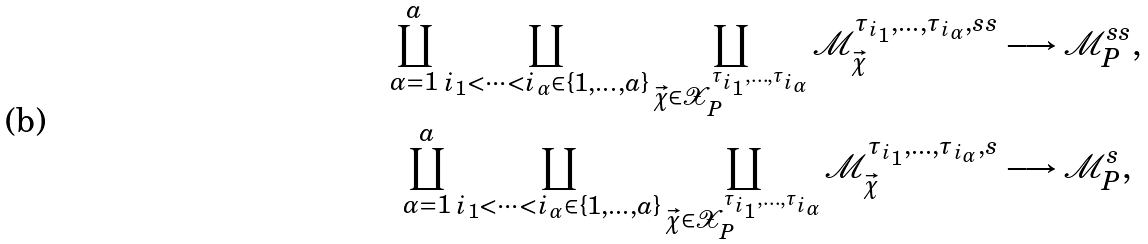<formula> <loc_0><loc_0><loc_500><loc_500>\coprod _ { \alpha = 1 } ^ { a } \coprod _ { i _ { 1 } < \cdots < i _ { \alpha } \in \{ 1 , \dots , a \} } \coprod _ { \vec { \chi } \in \mathcal { X } _ { P } ^ { \tau _ { i _ { 1 } } , \dots , \tau _ { i _ { \alpha } } } } \mathcal { M } _ { \vec { \chi } } ^ { \tau _ { i _ { 1 } } , \dots , \tau _ { i _ { \alpha } } , s s } & \longrightarrow \mathcal { M } _ { P } ^ { s s } , \\ \coprod _ { \alpha = 1 } ^ { a } \coprod _ { i _ { 1 } < \cdots < i _ { \alpha } \in \{ 1 , \dots , a \} } \coprod _ { \vec { \chi } \in \mathcal { X } _ { P } ^ { \tau _ { i _ { 1 } } , \dots , \tau _ { i _ { \alpha } } } } \mathcal { M } _ { \vec { \chi } } ^ { \tau _ { i _ { 1 } } , \dots , \tau _ { i _ { \alpha } } , s } & \longrightarrow \mathcal { M } _ { P } ^ { s } ,</formula> 